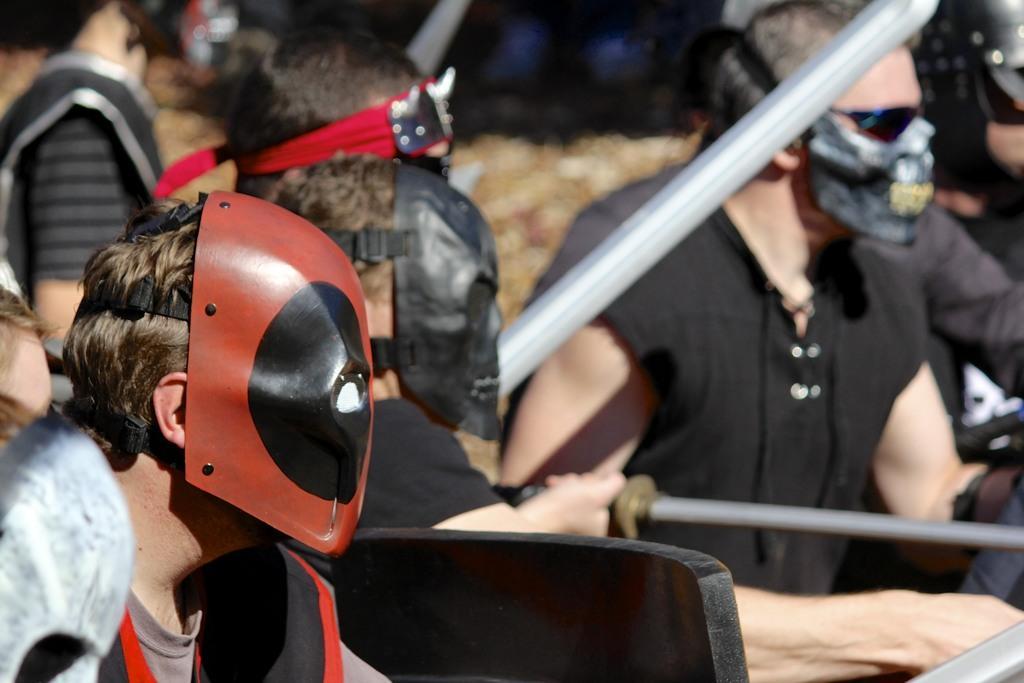Can you describe this image briefly? In this image there are a few people wearing mask on their face and they are holding some objects in their hands. 